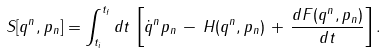Convert formula to latex. <formula><loc_0><loc_0><loc_500><loc_500>S [ q ^ { n } , p _ { n } ] = \int _ { t _ { i } } ^ { t _ { f } } d t \, \left [ \dot { q } ^ { n } p _ { n } \, - \, H ( q ^ { n } , p _ { n } ) \, + \, \frac { d F ( q ^ { n } , p _ { n } ) } { d t } \right ] .</formula> 